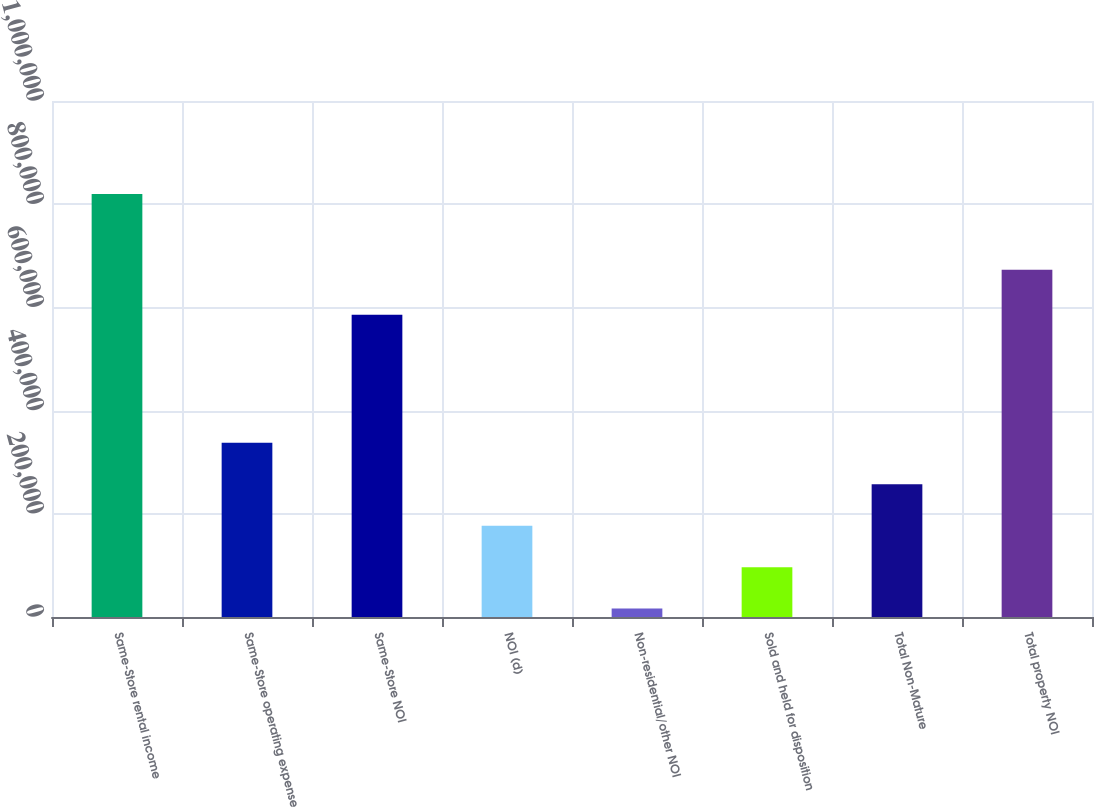<chart> <loc_0><loc_0><loc_500><loc_500><bar_chart><fcel>Same-Store rental income<fcel>Same-Store operating expense<fcel>Same-Store NOI<fcel>NOI (d)<fcel>Non-residential/other NOI<fcel>Sold and held for disposition<fcel>Total Non-Mature<fcel>Total property NOI<nl><fcel>819962<fcel>337731<fcel>585577<fcel>176988<fcel>16244<fcel>96615.8<fcel>257359<fcel>673085<nl></chart> 